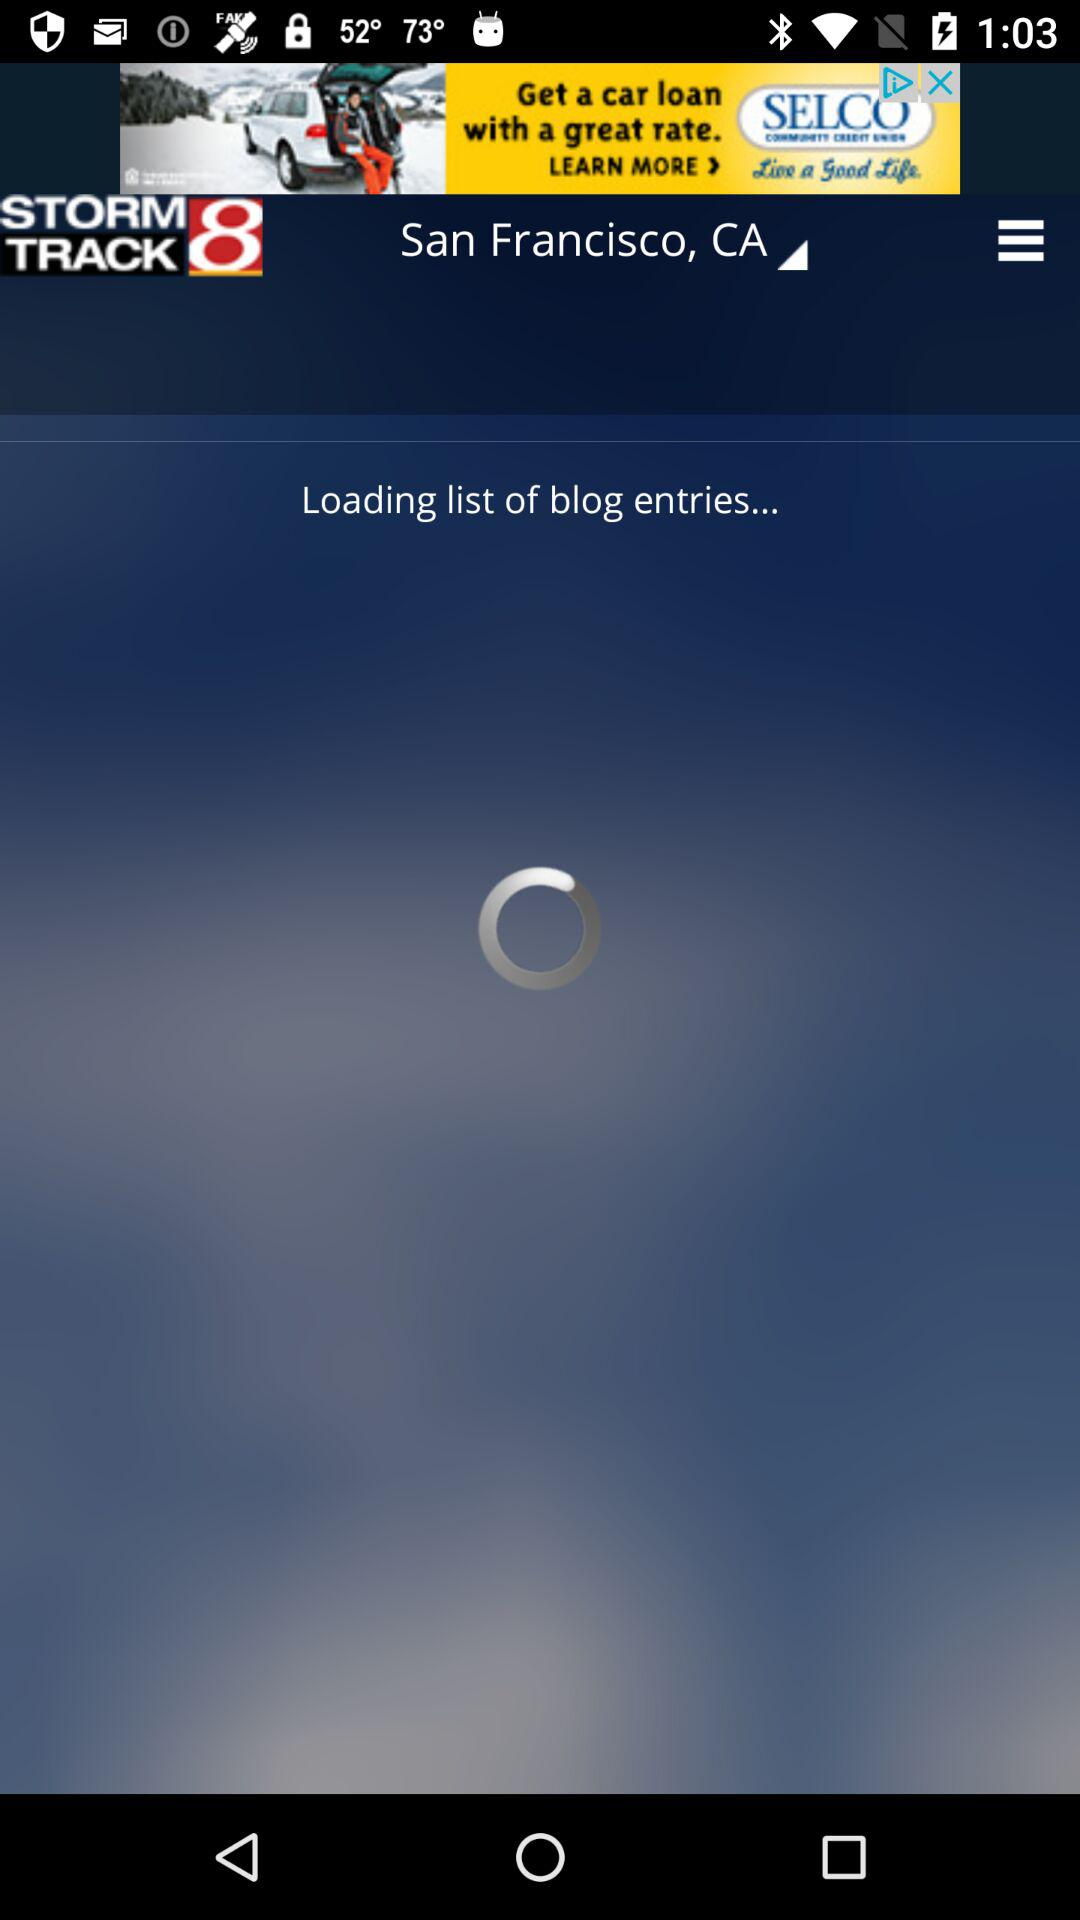What is the location? The location is San Francisco, CA. 